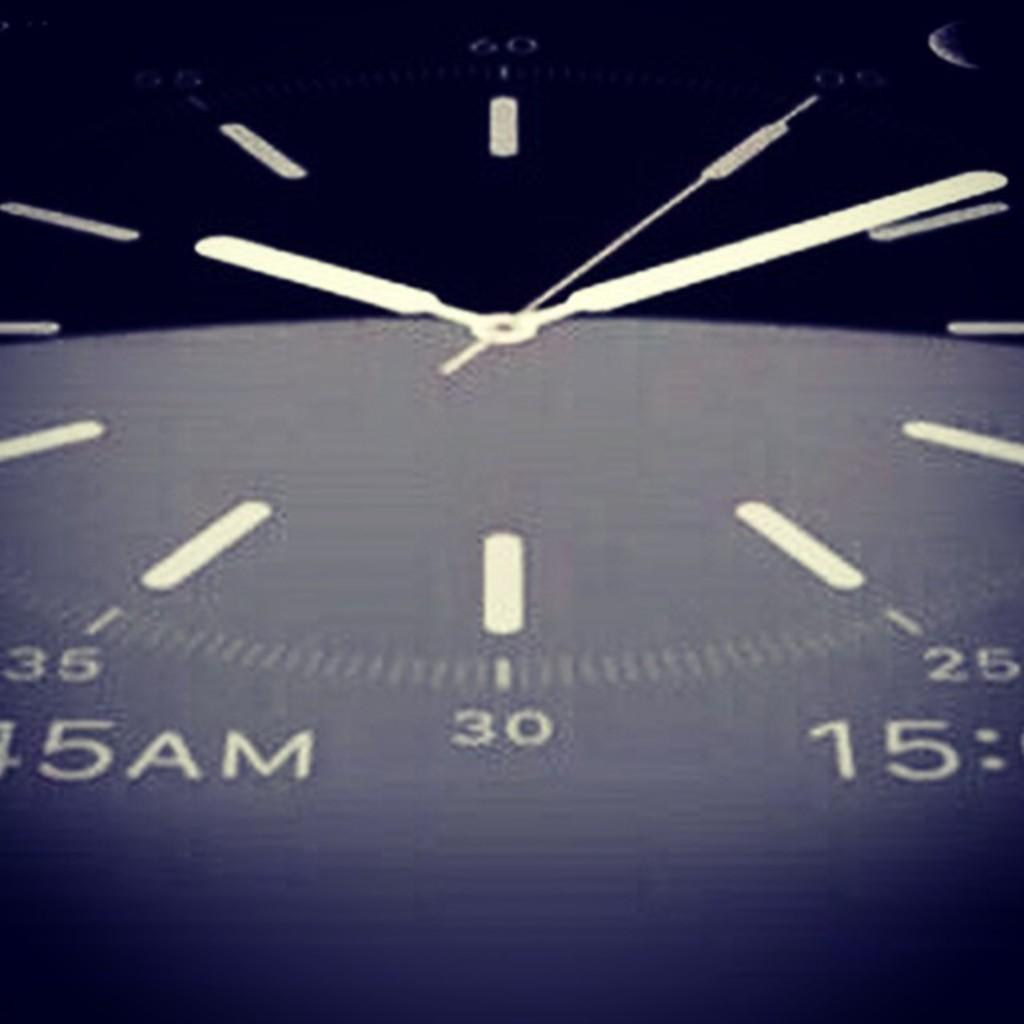Provide a one-sentence caption for the provided image. A zoomed in look at a watch that shows 30. 